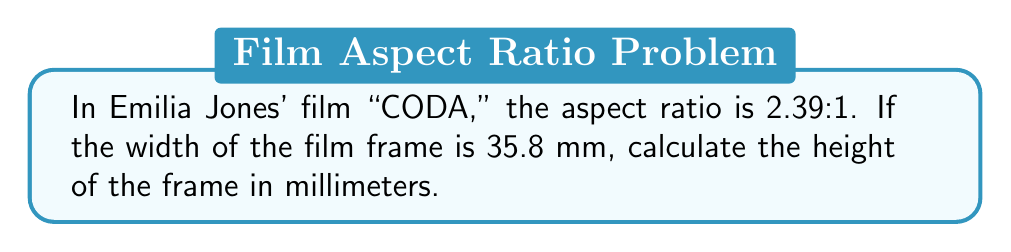Provide a solution to this math problem. To solve this problem, we need to use the given aspect ratio and the width of the film frame. Let's break it down step-by-step:

1. The aspect ratio is given as 2.39:1, which means:
   $$ \frac{\text{width}}{\text{height}} = \frac{2.39}{1} $$

2. We know the width is 35.8 mm, so we can set up the equation:
   $$ \frac{35.8}{\text{height}} = \frac{2.39}{1} $$

3. To solve for the height, we can cross-multiply:
   $$ 35.8 \times 1 = 2.39 \times \text{height} $$

4. Simplify:
   $$ 35.8 = 2.39 \times \text{height} $$

5. Divide both sides by 2.39:
   $$ \frac{35.8}{2.39} = \text{height} $$

6. Calculate the result:
   $$ \text{height} = 14.979... \text{ mm} $$

7. Round to two decimal places for a practical measurement:
   $$ \text{height} \approx 14.98 \text{ mm} $$

This calculation gives us the height of the film frame used in "CODA," which is consistent with the widescreen format commonly used in modern cinema.
Answer: 14.98 mm 